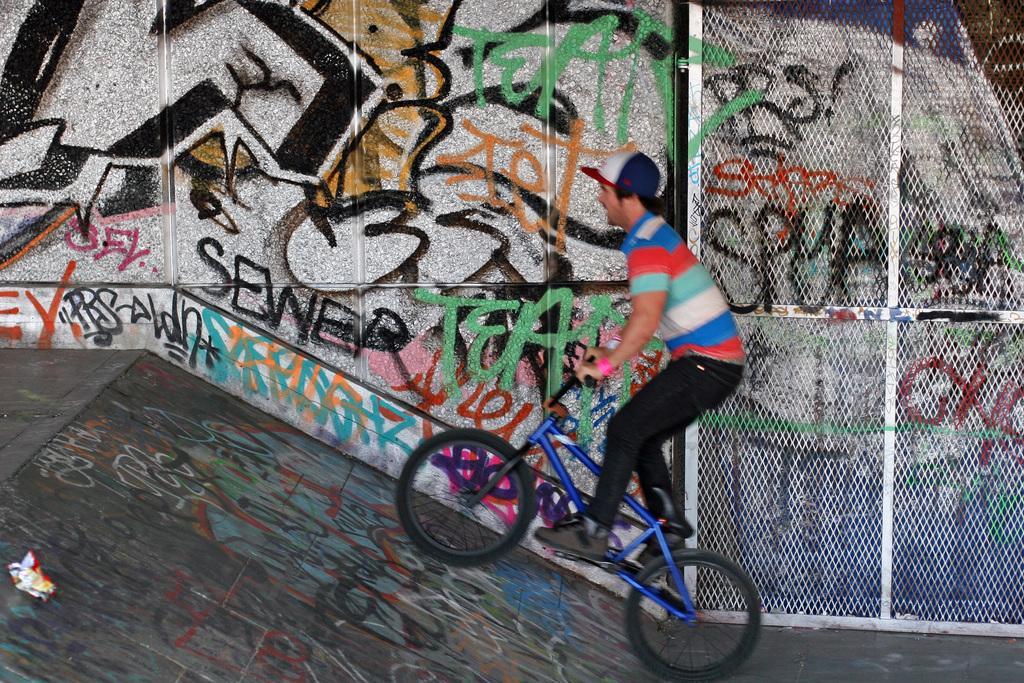In one or two sentences, can you explain what this image depicts? There is a man riding a bicycle and he wore a cap. In the background we can see a wall. 